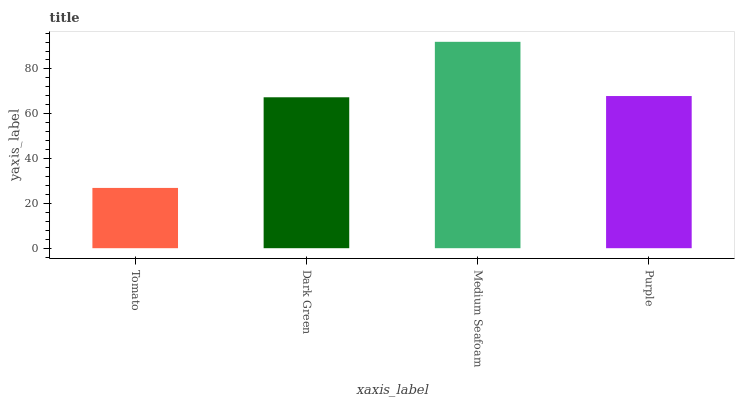Is Tomato the minimum?
Answer yes or no. Yes. Is Medium Seafoam the maximum?
Answer yes or no. Yes. Is Dark Green the minimum?
Answer yes or no. No. Is Dark Green the maximum?
Answer yes or no. No. Is Dark Green greater than Tomato?
Answer yes or no. Yes. Is Tomato less than Dark Green?
Answer yes or no. Yes. Is Tomato greater than Dark Green?
Answer yes or no. No. Is Dark Green less than Tomato?
Answer yes or no. No. Is Purple the high median?
Answer yes or no. Yes. Is Dark Green the low median?
Answer yes or no. Yes. Is Dark Green the high median?
Answer yes or no. No. Is Tomato the low median?
Answer yes or no. No. 